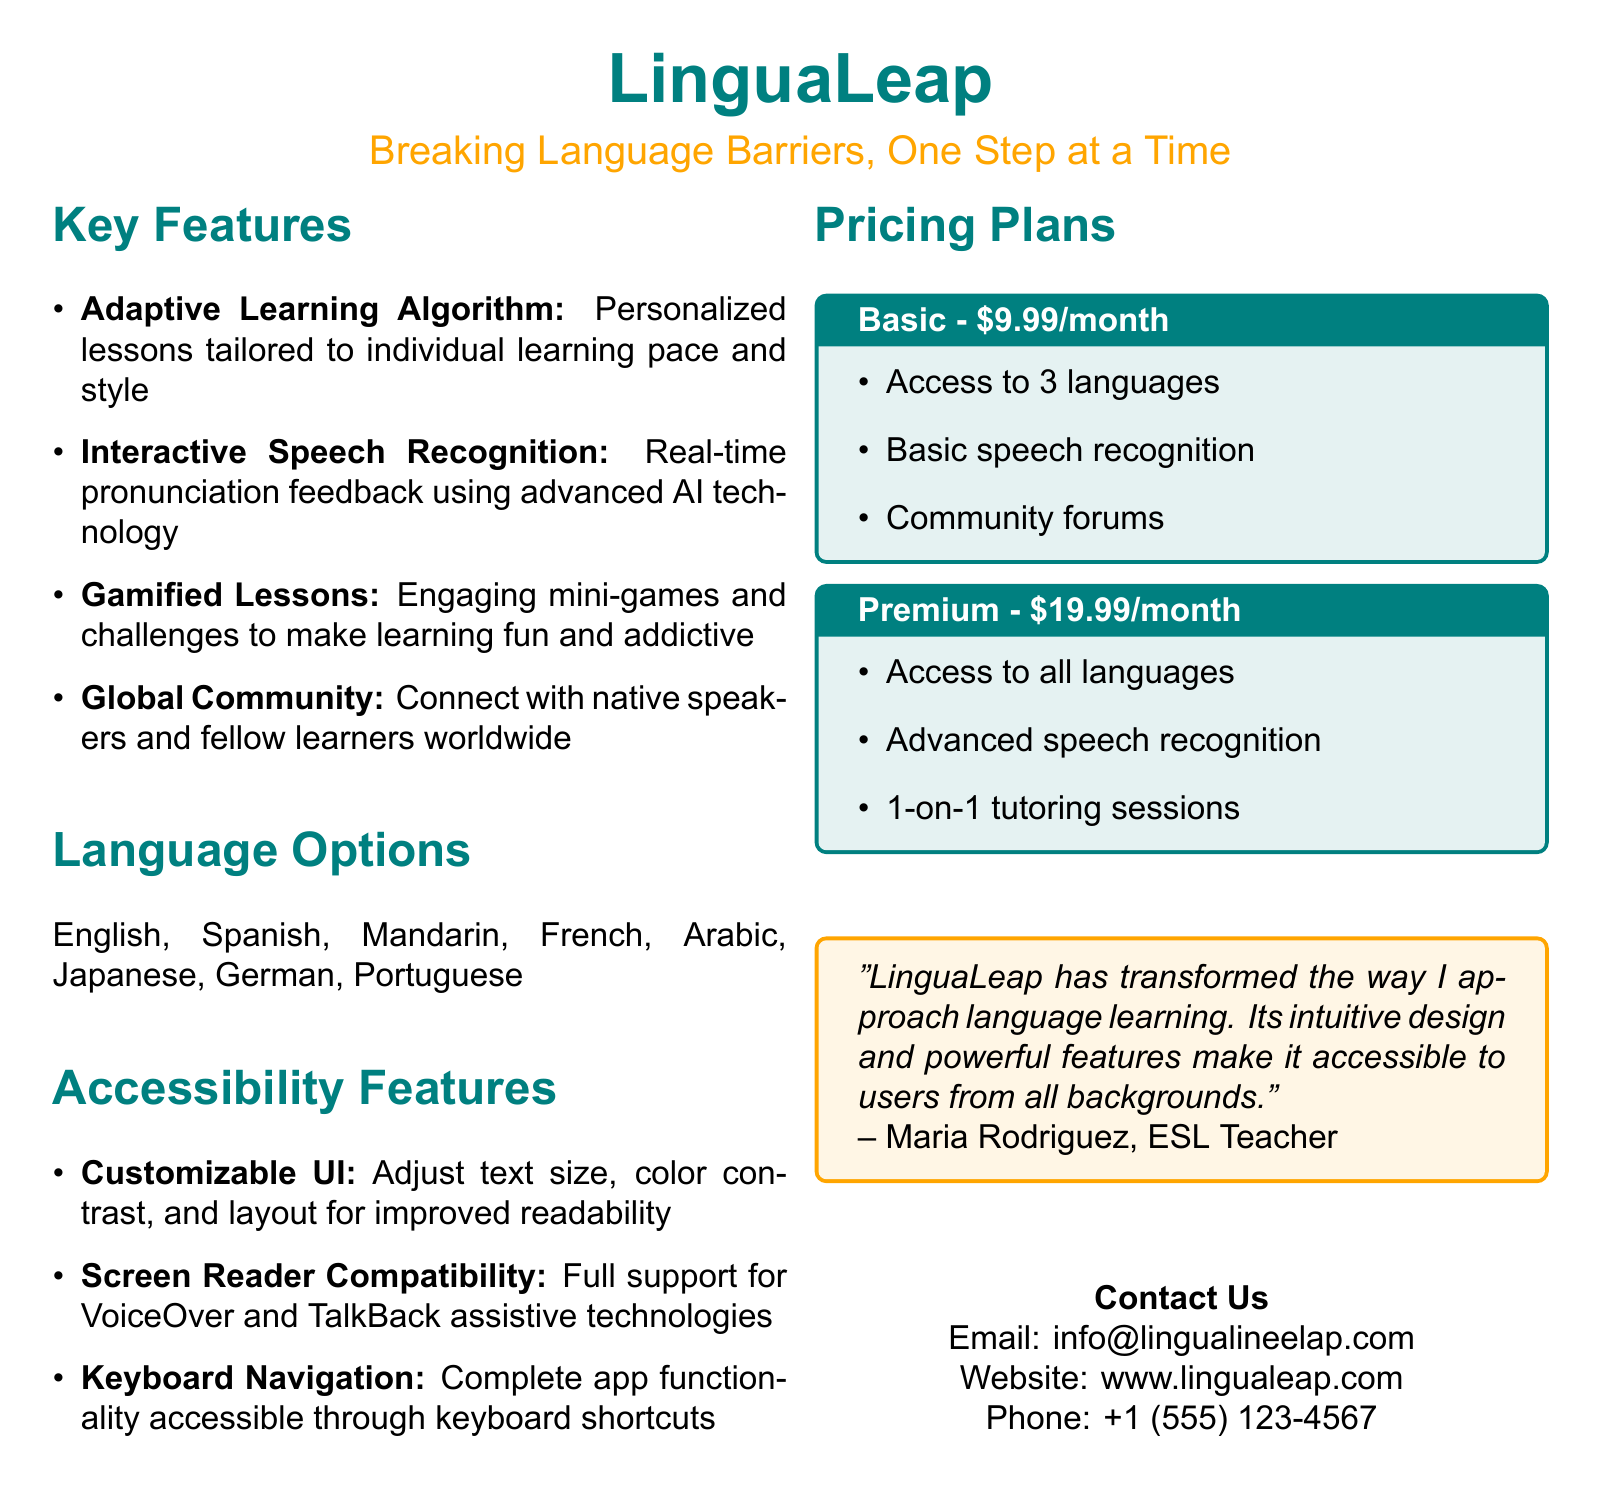What is the name of the app? The app is referred to as "LinguaLeap" in the document.
Answer: LinguaLeap What is the tagline of LinguaLeap? The tagline provided is "Breaking Language Barriers, One Step at a Time."
Answer: Breaking Language Barriers, One Step at a Time How many languages are available in the Premium plan? The Premium plan offers access to all languages listed in the document.
Answer: All languages What is the monthly cost of the Basic plan? The document states that the Basic plan costs $9.99 per month.
Answer: $9.99 What feature allows users to connect with native speakers? The feature mentioned for connecting with native speakers is part of the "Global Community."
Answer: Global Community What are users able to adjust in the Customizable UI? Users can adjust text size, color contrast, and layout for improved readability.
Answer: Text size, color contrast, layout How is the speech recognition in the Premium plan different from the Basic plan? The Premium plan offers advanced speech recognition, while the Basic plan provides basic speech recognition.
Answer: Advanced vs. Basic Which assistive technologies are supported by the app? The app provides full support for VoiceOver and TalkBack assistive technologies.
Answer: VoiceOver and TalkBack Who is quoted in the document praising LinguaLeap? The document features a quote from Maria Rodriguez, who is an ESL Teacher.
Answer: Maria Rodriguez 